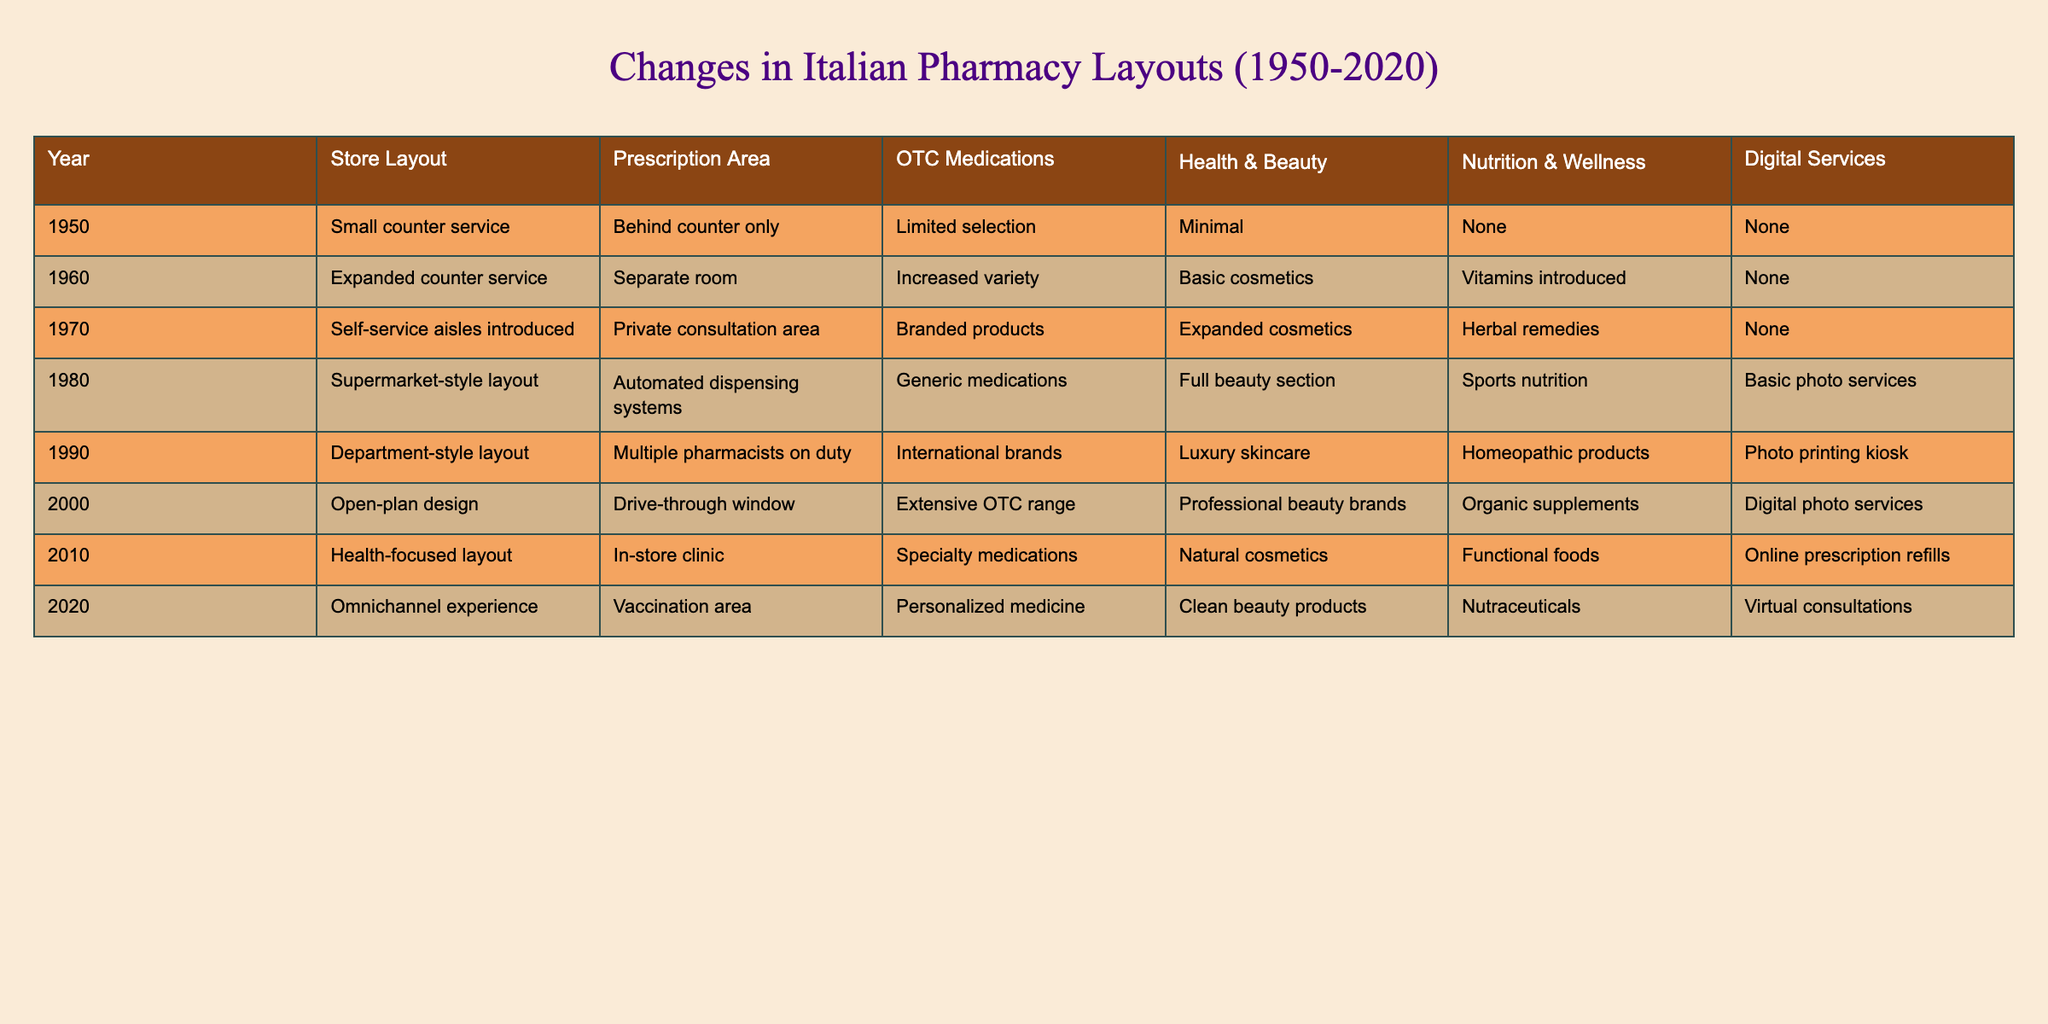What was the store layout in 1950? The table lists the store layout for each year, specifically indicating that in 1950, the layout was "Small counter service."
Answer: Small counter service Which year introduced the self-service aisles? Referring to the table, the introduction of self-service aisles is noted in the year 1970.
Answer: 1970 How has the prescription area changed from 1980 to 2020? In 1980, the prescription area was "Automated dispensing systems," while in 2020, it included a "Vaccination area." This indicates a shift towards more interactive and health-focused services.
Answer: From automated systems to vaccination area Did the pharmacy offer OTC medications in 1950? According to the data, the table states there was a "Limited selection" of OTC medications in 1950, which indicates that they were available but not extensive.
Answer: Yes, but limited What is the average number of product offerings (categories) per decade from 1950 to 2020? Each decade has different product offerings. In total, from the categories (OTC Medications, Health & Beauty, Nutrition & Wellness, Digital Services), we can sum them for each decade: 1950 (3), 1960 (4), 1970 (5), 1980 (5), 1990 (5), 2000 (5), 2010 (5), 2020 (5) which totals 37. Dividing by 8 decades gives an average of 4.625.
Answer: 4.625 Which decade saw the introduction of drive-through windows for prescriptions? The table shows that drive-through windows were introduced in the year 2000, indicating a major shift in convenience for customers.
Answer: 2000 Was there a significant shift in digital services available between 2010 and 2020? Yes, the table indicates that in 2010, the digital services included "Online prescription refills," while in 2020 it expanded to "Virtual consultations," which shows an increase in services offered through digital means.
Answer: Yes In which year did health and beauty products expand the most based on the table? By comparing the health and beauty products across the years, the largest expansion appears to be from basic cosmetics in 1960 to a full beauty section in 1980, indicating that growth took place during this decade.
Answer: Between 1960 and 1980 Based on the table, which category of offerings has remained consistent across all decades? After reviewing the data, OTC medications have been present in every decade, though the selection has expanded significantly.
Answer: OTC medications 